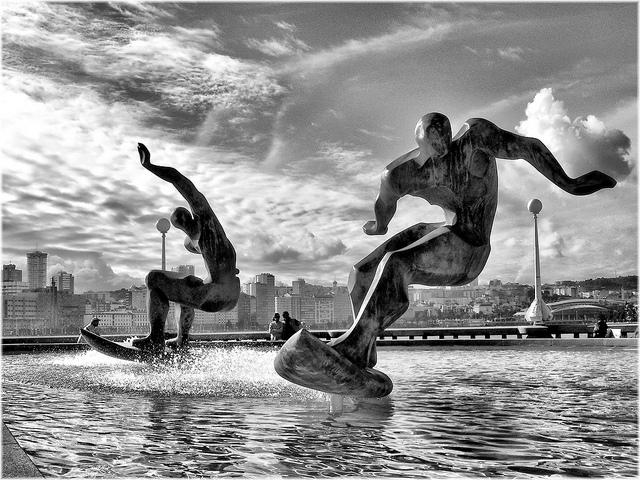What energy powers the splash?

Choices:
A) electricity
B) solar
C) wind
D) manual power electricity 